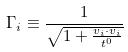Convert formula to latex. <formula><loc_0><loc_0><loc_500><loc_500>\Gamma _ { i } \equiv \frac { 1 } { \sqrt { 1 + \frac { v _ { i } \cdot v _ { i } } { t ^ { 0 } } } }</formula> 